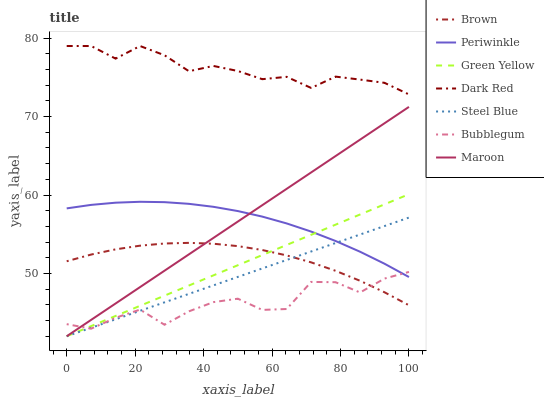Does Bubblegum have the minimum area under the curve?
Answer yes or no. Yes. Does Dark Red have the maximum area under the curve?
Answer yes or no. Yes. Does Steel Blue have the minimum area under the curve?
Answer yes or no. No. Does Steel Blue have the maximum area under the curve?
Answer yes or no. No. Is Green Yellow the smoothest?
Answer yes or no. Yes. Is Bubblegum the roughest?
Answer yes or no. Yes. Is Dark Red the smoothest?
Answer yes or no. No. Is Dark Red the roughest?
Answer yes or no. No. Does Steel Blue have the lowest value?
Answer yes or no. Yes. Does Dark Red have the lowest value?
Answer yes or no. No. Does Dark Red have the highest value?
Answer yes or no. Yes. Does Steel Blue have the highest value?
Answer yes or no. No. Is Green Yellow less than Dark Red?
Answer yes or no. Yes. Is Periwinkle greater than Brown?
Answer yes or no. Yes. Does Maroon intersect Green Yellow?
Answer yes or no. Yes. Is Maroon less than Green Yellow?
Answer yes or no. No. Is Maroon greater than Green Yellow?
Answer yes or no. No. Does Green Yellow intersect Dark Red?
Answer yes or no. No. 